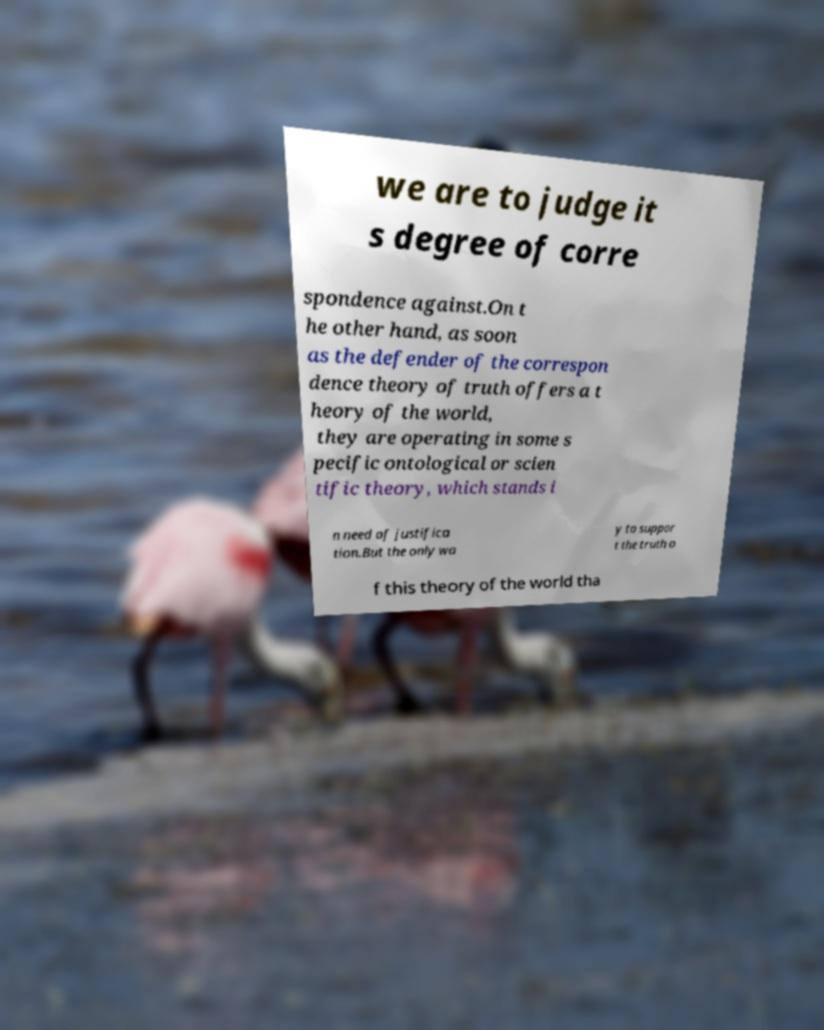Could you extract and type out the text from this image? we are to judge it s degree of corre spondence against.On t he other hand, as soon as the defender of the correspon dence theory of truth offers a t heory of the world, they are operating in some s pecific ontological or scien tific theory, which stands i n need of justifica tion.But the only wa y to suppor t the truth o f this theory of the world tha 